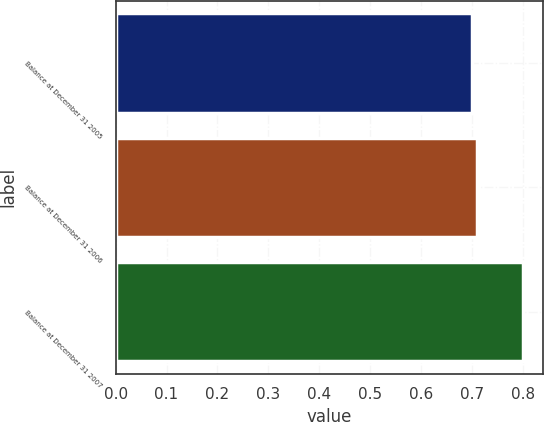Convert chart to OTSL. <chart><loc_0><loc_0><loc_500><loc_500><bar_chart><fcel>Balance at December 31 2005<fcel>Balance at December 31 2006<fcel>Balance at December 31 2007<nl><fcel>0.7<fcel>0.71<fcel>0.8<nl></chart> 